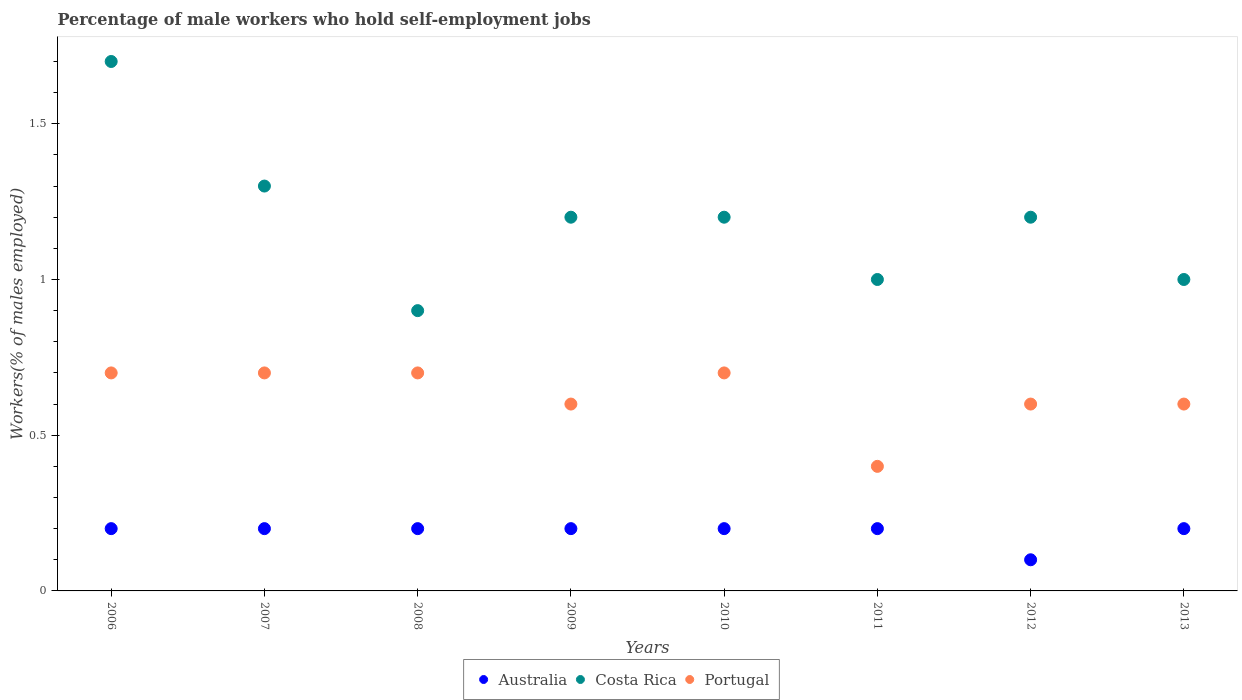How many different coloured dotlines are there?
Offer a very short reply. 3. What is the percentage of self-employed male workers in Australia in 2006?
Keep it short and to the point. 0.2. Across all years, what is the maximum percentage of self-employed male workers in Portugal?
Make the answer very short. 0.7. Across all years, what is the minimum percentage of self-employed male workers in Australia?
Keep it short and to the point. 0.1. What is the total percentage of self-employed male workers in Costa Rica in the graph?
Your answer should be very brief. 9.5. What is the difference between the percentage of self-employed male workers in Portugal in 2007 and that in 2009?
Your answer should be very brief. 0.1. What is the difference between the percentage of self-employed male workers in Australia in 2010 and the percentage of self-employed male workers in Portugal in 2012?
Provide a succinct answer. -0.4. What is the average percentage of self-employed male workers in Australia per year?
Keep it short and to the point. 0.19. In the year 2011, what is the difference between the percentage of self-employed male workers in Australia and percentage of self-employed male workers in Costa Rica?
Make the answer very short. -0.8. What is the ratio of the percentage of self-employed male workers in Costa Rica in 2006 to that in 2009?
Provide a succinct answer. 1.42. Is the percentage of self-employed male workers in Costa Rica in 2010 less than that in 2013?
Make the answer very short. No. Is the difference between the percentage of self-employed male workers in Australia in 2007 and 2010 greater than the difference between the percentage of self-employed male workers in Costa Rica in 2007 and 2010?
Your answer should be very brief. No. What is the difference between the highest and the second highest percentage of self-employed male workers in Costa Rica?
Provide a short and direct response. 0.4. What is the difference between the highest and the lowest percentage of self-employed male workers in Portugal?
Your answer should be very brief. 0.3. In how many years, is the percentage of self-employed male workers in Australia greater than the average percentage of self-employed male workers in Australia taken over all years?
Give a very brief answer. 7. Does the percentage of self-employed male workers in Portugal monotonically increase over the years?
Give a very brief answer. No. How many dotlines are there?
Offer a very short reply. 3. Does the graph contain any zero values?
Make the answer very short. No. Does the graph contain grids?
Provide a succinct answer. No. Where does the legend appear in the graph?
Keep it short and to the point. Bottom center. How many legend labels are there?
Your answer should be compact. 3. What is the title of the graph?
Offer a terse response. Percentage of male workers who hold self-employment jobs. Does "Namibia" appear as one of the legend labels in the graph?
Ensure brevity in your answer.  No. What is the label or title of the Y-axis?
Keep it short and to the point. Workers(% of males employed). What is the Workers(% of males employed) of Australia in 2006?
Give a very brief answer. 0.2. What is the Workers(% of males employed) in Costa Rica in 2006?
Provide a succinct answer. 1.7. What is the Workers(% of males employed) in Portugal in 2006?
Offer a terse response. 0.7. What is the Workers(% of males employed) of Australia in 2007?
Your response must be concise. 0.2. What is the Workers(% of males employed) in Costa Rica in 2007?
Your answer should be very brief. 1.3. What is the Workers(% of males employed) in Portugal in 2007?
Offer a terse response. 0.7. What is the Workers(% of males employed) in Australia in 2008?
Provide a succinct answer. 0.2. What is the Workers(% of males employed) in Costa Rica in 2008?
Your answer should be very brief. 0.9. What is the Workers(% of males employed) of Portugal in 2008?
Make the answer very short. 0.7. What is the Workers(% of males employed) of Australia in 2009?
Keep it short and to the point. 0.2. What is the Workers(% of males employed) in Costa Rica in 2009?
Offer a very short reply. 1.2. What is the Workers(% of males employed) of Portugal in 2009?
Your response must be concise. 0.6. What is the Workers(% of males employed) of Australia in 2010?
Ensure brevity in your answer.  0.2. What is the Workers(% of males employed) of Costa Rica in 2010?
Provide a succinct answer. 1.2. What is the Workers(% of males employed) of Portugal in 2010?
Offer a very short reply. 0.7. What is the Workers(% of males employed) in Australia in 2011?
Keep it short and to the point. 0.2. What is the Workers(% of males employed) of Costa Rica in 2011?
Your answer should be very brief. 1. What is the Workers(% of males employed) of Portugal in 2011?
Your response must be concise. 0.4. What is the Workers(% of males employed) of Australia in 2012?
Ensure brevity in your answer.  0.1. What is the Workers(% of males employed) in Costa Rica in 2012?
Give a very brief answer. 1.2. What is the Workers(% of males employed) in Portugal in 2012?
Your answer should be compact. 0.6. What is the Workers(% of males employed) in Australia in 2013?
Offer a very short reply. 0.2. What is the Workers(% of males employed) in Costa Rica in 2013?
Offer a very short reply. 1. What is the Workers(% of males employed) in Portugal in 2013?
Keep it short and to the point. 0.6. Across all years, what is the maximum Workers(% of males employed) in Australia?
Your answer should be compact. 0.2. Across all years, what is the maximum Workers(% of males employed) in Costa Rica?
Provide a short and direct response. 1.7. Across all years, what is the maximum Workers(% of males employed) of Portugal?
Your response must be concise. 0.7. Across all years, what is the minimum Workers(% of males employed) of Australia?
Keep it short and to the point. 0.1. Across all years, what is the minimum Workers(% of males employed) of Costa Rica?
Offer a very short reply. 0.9. Across all years, what is the minimum Workers(% of males employed) of Portugal?
Provide a succinct answer. 0.4. What is the total Workers(% of males employed) of Australia in the graph?
Your answer should be compact. 1.5. What is the difference between the Workers(% of males employed) in Australia in 2006 and that in 2007?
Ensure brevity in your answer.  0. What is the difference between the Workers(% of males employed) of Portugal in 2006 and that in 2007?
Your response must be concise. 0. What is the difference between the Workers(% of males employed) in Portugal in 2006 and that in 2008?
Provide a succinct answer. 0. What is the difference between the Workers(% of males employed) of Australia in 2006 and that in 2009?
Offer a terse response. 0. What is the difference between the Workers(% of males employed) in Costa Rica in 2006 and that in 2009?
Offer a very short reply. 0.5. What is the difference between the Workers(% of males employed) of Portugal in 2006 and that in 2009?
Give a very brief answer. 0.1. What is the difference between the Workers(% of males employed) in Australia in 2006 and that in 2010?
Ensure brevity in your answer.  0. What is the difference between the Workers(% of males employed) of Portugal in 2006 and that in 2010?
Give a very brief answer. 0. What is the difference between the Workers(% of males employed) of Portugal in 2006 and that in 2011?
Offer a terse response. 0.3. What is the difference between the Workers(% of males employed) of Australia in 2006 and that in 2012?
Make the answer very short. 0.1. What is the difference between the Workers(% of males employed) in Costa Rica in 2006 and that in 2012?
Your response must be concise. 0.5. What is the difference between the Workers(% of males employed) in Portugal in 2006 and that in 2012?
Ensure brevity in your answer.  0.1. What is the difference between the Workers(% of males employed) in Australia in 2006 and that in 2013?
Ensure brevity in your answer.  0. What is the difference between the Workers(% of males employed) of Costa Rica in 2006 and that in 2013?
Ensure brevity in your answer.  0.7. What is the difference between the Workers(% of males employed) of Portugal in 2006 and that in 2013?
Your answer should be compact. 0.1. What is the difference between the Workers(% of males employed) of Costa Rica in 2007 and that in 2008?
Give a very brief answer. 0.4. What is the difference between the Workers(% of males employed) in Costa Rica in 2007 and that in 2009?
Offer a very short reply. 0.1. What is the difference between the Workers(% of males employed) of Australia in 2007 and that in 2011?
Keep it short and to the point. 0. What is the difference between the Workers(% of males employed) in Costa Rica in 2007 and that in 2011?
Ensure brevity in your answer.  0.3. What is the difference between the Workers(% of males employed) of Portugal in 2007 and that in 2011?
Give a very brief answer. 0.3. What is the difference between the Workers(% of males employed) in Costa Rica in 2007 and that in 2012?
Offer a terse response. 0.1. What is the difference between the Workers(% of males employed) of Portugal in 2007 and that in 2012?
Provide a short and direct response. 0.1. What is the difference between the Workers(% of males employed) of Portugal in 2007 and that in 2013?
Keep it short and to the point. 0.1. What is the difference between the Workers(% of males employed) in Australia in 2008 and that in 2009?
Your answer should be compact. 0. What is the difference between the Workers(% of males employed) of Costa Rica in 2008 and that in 2010?
Your answer should be very brief. -0.3. What is the difference between the Workers(% of males employed) of Portugal in 2008 and that in 2010?
Give a very brief answer. 0. What is the difference between the Workers(% of males employed) in Costa Rica in 2008 and that in 2013?
Keep it short and to the point. -0.1. What is the difference between the Workers(% of males employed) in Australia in 2009 and that in 2010?
Keep it short and to the point. 0. What is the difference between the Workers(% of males employed) in Costa Rica in 2009 and that in 2010?
Make the answer very short. 0. What is the difference between the Workers(% of males employed) of Portugal in 2009 and that in 2010?
Offer a very short reply. -0.1. What is the difference between the Workers(% of males employed) in Australia in 2009 and that in 2012?
Provide a short and direct response. 0.1. What is the difference between the Workers(% of males employed) of Costa Rica in 2009 and that in 2013?
Your answer should be compact. 0.2. What is the difference between the Workers(% of males employed) in Portugal in 2009 and that in 2013?
Give a very brief answer. 0. What is the difference between the Workers(% of males employed) in Australia in 2010 and that in 2011?
Provide a short and direct response. 0. What is the difference between the Workers(% of males employed) of Portugal in 2010 and that in 2011?
Your answer should be very brief. 0.3. What is the difference between the Workers(% of males employed) of Australia in 2010 and that in 2013?
Your response must be concise. 0. What is the difference between the Workers(% of males employed) in Costa Rica in 2010 and that in 2013?
Provide a short and direct response. 0.2. What is the difference between the Workers(% of males employed) of Australia in 2011 and that in 2012?
Your response must be concise. 0.1. What is the difference between the Workers(% of males employed) in Costa Rica in 2011 and that in 2012?
Ensure brevity in your answer.  -0.2. What is the difference between the Workers(% of males employed) in Portugal in 2011 and that in 2012?
Your response must be concise. -0.2. What is the difference between the Workers(% of males employed) of Costa Rica in 2011 and that in 2013?
Give a very brief answer. 0. What is the difference between the Workers(% of males employed) of Portugal in 2011 and that in 2013?
Keep it short and to the point. -0.2. What is the difference between the Workers(% of males employed) in Portugal in 2012 and that in 2013?
Your answer should be compact. 0. What is the difference between the Workers(% of males employed) in Australia in 2006 and the Workers(% of males employed) in Costa Rica in 2007?
Keep it short and to the point. -1.1. What is the difference between the Workers(% of males employed) of Australia in 2006 and the Workers(% of males employed) of Costa Rica in 2008?
Provide a short and direct response. -0.7. What is the difference between the Workers(% of males employed) in Australia in 2006 and the Workers(% of males employed) in Portugal in 2008?
Offer a very short reply. -0.5. What is the difference between the Workers(% of males employed) in Costa Rica in 2006 and the Workers(% of males employed) in Portugal in 2008?
Your answer should be very brief. 1. What is the difference between the Workers(% of males employed) of Costa Rica in 2006 and the Workers(% of males employed) of Portugal in 2009?
Your answer should be very brief. 1.1. What is the difference between the Workers(% of males employed) in Australia in 2006 and the Workers(% of males employed) in Costa Rica in 2010?
Provide a succinct answer. -1. What is the difference between the Workers(% of males employed) in Australia in 2006 and the Workers(% of males employed) in Portugal in 2011?
Offer a terse response. -0.2. What is the difference between the Workers(% of males employed) of Australia in 2006 and the Workers(% of males employed) of Costa Rica in 2012?
Offer a terse response. -1. What is the difference between the Workers(% of males employed) of Australia in 2006 and the Workers(% of males employed) of Portugal in 2013?
Offer a terse response. -0.4. What is the difference between the Workers(% of males employed) of Costa Rica in 2006 and the Workers(% of males employed) of Portugal in 2013?
Give a very brief answer. 1.1. What is the difference between the Workers(% of males employed) of Australia in 2007 and the Workers(% of males employed) of Costa Rica in 2008?
Give a very brief answer. -0.7. What is the difference between the Workers(% of males employed) of Australia in 2007 and the Workers(% of males employed) of Costa Rica in 2010?
Offer a very short reply. -1. What is the difference between the Workers(% of males employed) in Australia in 2007 and the Workers(% of males employed) in Portugal in 2010?
Your response must be concise. -0.5. What is the difference between the Workers(% of males employed) of Australia in 2007 and the Workers(% of males employed) of Costa Rica in 2011?
Your answer should be compact. -0.8. What is the difference between the Workers(% of males employed) of Costa Rica in 2007 and the Workers(% of males employed) of Portugal in 2011?
Offer a terse response. 0.9. What is the difference between the Workers(% of males employed) of Australia in 2007 and the Workers(% of males employed) of Costa Rica in 2013?
Make the answer very short. -0.8. What is the difference between the Workers(% of males employed) of Australia in 2007 and the Workers(% of males employed) of Portugal in 2013?
Offer a terse response. -0.4. What is the difference between the Workers(% of males employed) in Costa Rica in 2007 and the Workers(% of males employed) in Portugal in 2013?
Your answer should be very brief. 0.7. What is the difference between the Workers(% of males employed) of Australia in 2008 and the Workers(% of males employed) of Costa Rica in 2009?
Make the answer very short. -1. What is the difference between the Workers(% of males employed) of Costa Rica in 2008 and the Workers(% of males employed) of Portugal in 2009?
Your response must be concise. 0.3. What is the difference between the Workers(% of males employed) of Australia in 2008 and the Workers(% of males employed) of Costa Rica in 2010?
Your answer should be compact. -1. What is the difference between the Workers(% of males employed) of Australia in 2008 and the Workers(% of males employed) of Portugal in 2010?
Provide a short and direct response. -0.5. What is the difference between the Workers(% of males employed) of Costa Rica in 2008 and the Workers(% of males employed) of Portugal in 2010?
Provide a succinct answer. 0.2. What is the difference between the Workers(% of males employed) in Costa Rica in 2008 and the Workers(% of males employed) in Portugal in 2011?
Your response must be concise. 0.5. What is the difference between the Workers(% of males employed) in Australia in 2008 and the Workers(% of males employed) in Costa Rica in 2012?
Your answer should be very brief. -1. What is the difference between the Workers(% of males employed) of Australia in 2008 and the Workers(% of males employed) of Portugal in 2012?
Make the answer very short. -0.4. What is the difference between the Workers(% of males employed) of Costa Rica in 2008 and the Workers(% of males employed) of Portugal in 2012?
Give a very brief answer. 0.3. What is the difference between the Workers(% of males employed) of Australia in 2008 and the Workers(% of males employed) of Costa Rica in 2013?
Give a very brief answer. -0.8. What is the difference between the Workers(% of males employed) in Australia in 2009 and the Workers(% of males employed) in Costa Rica in 2010?
Keep it short and to the point. -1. What is the difference between the Workers(% of males employed) of Costa Rica in 2009 and the Workers(% of males employed) of Portugal in 2010?
Keep it short and to the point. 0.5. What is the difference between the Workers(% of males employed) of Australia in 2009 and the Workers(% of males employed) of Portugal in 2011?
Give a very brief answer. -0.2. What is the difference between the Workers(% of males employed) of Australia in 2009 and the Workers(% of males employed) of Portugal in 2012?
Your answer should be compact. -0.4. What is the difference between the Workers(% of males employed) of Costa Rica in 2009 and the Workers(% of males employed) of Portugal in 2012?
Your answer should be compact. 0.6. What is the difference between the Workers(% of males employed) in Australia in 2010 and the Workers(% of males employed) in Costa Rica in 2011?
Offer a very short reply. -0.8. What is the difference between the Workers(% of males employed) in Australia in 2010 and the Workers(% of males employed) in Portugal in 2012?
Give a very brief answer. -0.4. What is the difference between the Workers(% of males employed) of Australia in 2010 and the Workers(% of males employed) of Portugal in 2013?
Ensure brevity in your answer.  -0.4. What is the difference between the Workers(% of males employed) of Costa Rica in 2011 and the Workers(% of males employed) of Portugal in 2012?
Provide a succinct answer. 0.4. What is the difference between the Workers(% of males employed) in Australia in 2011 and the Workers(% of males employed) in Costa Rica in 2013?
Make the answer very short. -0.8. What is the difference between the Workers(% of males employed) in Australia in 2011 and the Workers(% of males employed) in Portugal in 2013?
Provide a short and direct response. -0.4. What is the difference between the Workers(% of males employed) in Costa Rica in 2011 and the Workers(% of males employed) in Portugal in 2013?
Your answer should be compact. 0.4. What is the difference between the Workers(% of males employed) of Costa Rica in 2012 and the Workers(% of males employed) of Portugal in 2013?
Keep it short and to the point. 0.6. What is the average Workers(% of males employed) of Australia per year?
Offer a terse response. 0.19. What is the average Workers(% of males employed) of Costa Rica per year?
Your response must be concise. 1.19. What is the average Workers(% of males employed) in Portugal per year?
Give a very brief answer. 0.62. In the year 2006, what is the difference between the Workers(% of males employed) in Australia and Workers(% of males employed) in Portugal?
Your answer should be compact. -0.5. In the year 2006, what is the difference between the Workers(% of males employed) in Costa Rica and Workers(% of males employed) in Portugal?
Your answer should be very brief. 1. In the year 2008, what is the difference between the Workers(% of males employed) of Australia and Workers(% of males employed) of Portugal?
Keep it short and to the point. -0.5. In the year 2008, what is the difference between the Workers(% of males employed) of Costa Rica and Workers(% of males employed) of Portugal?
Offer a very short reply. 0.2. In the year 2009, what is the difference between the Workers(% of males employed) in Australia and Workers(% of males employed) in Costa Rica?
Ensure brevity in your answer.  -1. In the year 2009, what is the difference between the Workers(% of males employed) in Australia and Workers(% of males employed) in Portugal?
Provide a succinct answer. -0.4. In the year 2009, what is the difference between the Workers(% of males employed) in Costa Rica and Workers(% of males employed) in Portugal?
Your answer should be compact. 0.6. In the year 2010, what is the difference between the Workers(% of males employed) of Australia and Workers(% of males employed) of Costa Rica?
Make the answer very short. -1. In the year 2010, what is the difference between the Workers(% of males employed) in Australia and Workers(% of males employed) in Portugal?
Ensure brevity in your answer.  -0.5. In the year 2010, what is the difference between the Workers(% of males employed) in Costa Rica and Workers(% of males employed) in Portugal?
Offer a very short reply. 0.5. In the year 2012, what is the difference between the Workers(% of males employed) in Australia and Workers(% of males employed) in Costa Rica?
Keep it short and to the point. -1.1. In the year 2012, what is the difference between the Workers(% of males employed) of Australia and Workers(% of males employed) of Portugal?
Make the answer very short. -0.5. In the year 2012, what is the difference between the Workers(% of males employed) of Costa Rica and Workers(% of males employed) of Portugal?
Your answer should be very brief. 0.6. In the year 2013, what is the difference between the Workers(% of males employed) of Australia and Workers(% of males employed) of Costa Rica?
Offer a very short reply. -0.8. What is the ratio of the Workers(% of males employed) in Costa Rica in 2006 to that in 2007?
Give a very brief answer. 1.31. What is the ratio of the Workers(% of males employed) of Costa Rica in 2006 to that in 2008?
Provide a short and direct response. 1.89. What is the ratio of the Workers(% of males employed) in Portugal in 2006 to that in 2008?
Ensure brevity in your answer.  1. What is the ratio of the Workers(% of males employed) of Australia in 2006 to that in 2009?
Provide a short and direct response. 1. What is the ratio of the Workers(% of males employed) of Costa Rica in 2006 to that in 2009?
Your answer should be very brief. 1.42. What is the ratio of the Workers(% of males employed) in Costa Rica in 2006 to that in 2010?
Keep it short and to the point. 1.42. What is the ratio of the Workers(% of males employed) in Portugal in 2006 to that in 2010?
Offer a terse response. 1. What is the ratio of the Workers(% of males employed) in Australia in 2006 to that in 2011?
Keep it short and to the point. 1. What is the ratio of the Workers(% of males employed) of Australia in 2006 to that in 2012?
Provide a succinct answer. 2. What is the ratio of the Workers(% of males employed) of Costa Rica in 2006 to that in 2012?
Provide a short and direct response. 1.42. What is the ratio of the Workers(% of males employed) in Portugal in 2006 to that in 2012?
Provide a succinct answer. 1.17. What is the ratio of the Workers(% of males employed) in Australia in 2006 to that in 2013?
Ensure brevity in your answer.  1. What is the ratio of the Workers(% of males employed) of Costa Rica in 2006 to that in 2013?
Your answer should be compact. 1.7. What is the ratio of the Workers(% of males employed) of Portugal in 2006 to that in 2013?
Your answer should be compact. 1.17. What is the ratio of the Workers(% of males employed) in Australia in 2007 to that in 2008?
Make the answer very short. 1. What is the ratio of the Workers(% of males employed) of Costa Rica in 2007 to that in 2008?
Give a very brief answer. 1.44. What is the ratio of the Workers(% of males employed) in Portugal in 2007 to that in 2008?
Offer a terse response. 1. What is the ratio of the Workers(% of males employed) of Australia in 2007 to that in 2009?
Keep it short and to the point. 1. What is the ratio of the Workers(% of males employed) of Costa Rica in 2007 to that in 2009?
Give a very brief answer. 1.08. What is the ratio of the Workers(% of males employed) of Australia in 2007 to that in 2010?
Keep it short and to the point. 1. What is the ratio of the Workers(% of males employed) in Costa Rica in 2007 to that in 2010?
Keep it short and to the point. 1.08. What is the ratio of the Workers(% of males employed) in Portugal in 2007 to that in 2010?
Offer a terse response. 1. What is the ratio of the Workers(% of males employed) in Australia in 2007 to that in 2011?
Offer a terse response. 1. What is the ratio of the Workers(% of males employed) in Costa Rica in 2007 to that in 2011?
Your answer should be compact. 1.3. What is the ratio of the Workers(% of males employed) of Portugal in 2007 to that in 2011?
Your answer should be very brief. 1.75. What is the ratio of the Workers(% of males employed) of Costa Rica in 2007 to that in 2012?
Your response must be concise. 1.08. What is the ratio of the Workers(% of males employed) in Portugal in 2007 to that in 2012?
Provide a short and direct response. 1.17. What is the ratio of the Workers(% of males employed) in Australia in 2007 to that in 2013?
Your answer should be compact. 1. What is the ratio of the Workers(% of males employed) of Australia in 2008 to that in 2009?
Offer a terse response. 1. What is the ratio of the Workers(% of males employed) of Portugal in 2008 to that in 2009?
Provide a succinct answer. 1.17. What is the ratio of the Workers(% of males employed) of Australia in 2008 to that in 2010?
Provide a succinct answer. 1. What is the ratio of the Workers(% of males employed) in Costa Rica in 2008 to that in 2010?
Give a very brief answer. 0.75. What is the ratio of the Workers(% of males employed) in Costa Rica in 2008 to that in 2011?
Ensure brevity in your answer.  0.9. What is the ratio of the Workers(% of males employed) of Australia in 2008 to that in 2012?
Ensure brevity in your answer.  2. What is the ratio of the Workers(% of males employed) of Costa Rica in 2008 to that in 2012?
Your response must be concise. 0.75. What is the ratio of the Workers(% of males employed) of Portugal in 2008 to that in 2012?
Your response must be concise. 1.17. What is the ratio of the Workers(% of males employed) of Costa Rica in 2008 to that in 2013?
Provide a succinct answer. 0.9. What is the ratio of the Workers(% of males employed) in Portugal in 2008 to that in 2013?
Your answer should be compact. 1.17. What is the ratio of the Workers(% of males employed) of Australia in 2009 to that in 2010?
Offer a terse response. 1. What is the ratio of the Workers(% of males employed) in Costa Rica in 2009 to that in 2011?
Your answer should be very brief. 1.2. What is the ratio of the Workers(% of males employed) of Portugal in 2009 to that in 2011?
Keep it short and to the point. 1.5. What is the ratio of the Workers(% of males employed) of Australia in 2009 to that in 2012?
Offer a terse response. 2. What is the ratio of the Workers(% of males employed) in Costa Rica in 2009 to that in 2012?
Give a very brief answer. 1. What is the ratio of the Workers(% of males employed) of Australia in 2009 to that in 2013?
Your response must be concise. 1. What is the ratio of the Workers(% of males employed) of Costa Rica in 2009 to that in 2013?
Your answer should be very brief. 1.2. What is the ratio of the Workers(% of males employed) in Portugal in 2009 to that in 2013?
Your answer should be very brief. 1. What is the ratio of the Workers(% of males employed) in Costa Rica in 2010 to that in 2011?
Give a very brief answer. 1.2. What is the ratio of the Workers(% of males employed) in Portugal in 2010 to that in 2011?
Your answer should be very brief. 1.75. What is the ratio of the Workers(% of males employed) of Costa Rica in 2010 to that in 2012?
Your answer should be very brief. 1. What is the ratio of the Workers(% of males employed) in Portugal in 2010 to that in 2012?
Offer a very short reply. 1.17. What is the ratio of the Workers(% of males employed) of Australia in 2010 to that in 2013?
Offer a very short reply. 1. What is the ratio of the Workers(% of males employed) of Costa Rica in 2010 to that in 2013?
Offer a very short reply. 1.2. What is the ratio of the Workers(% of males employed) in Australia in 2011 to that in 2012?
Your answer should be very brief. 2. What is the ratio of the Workers(% of males employed) of Costa Rica in 2011 to that in 2012?
Provide a succinct answer. 0.83. What is the ratio of the Workers(% of males employed) of Portugal in 2011 to that in 2012?
Your response must be concise. 0.67. What is the ratio of the Workers(% of males employed) in Australia in 2011 to that in 2013?
Your response must be concise. 1. What is the ratio of the Workers(% of males employed) of Costa Rica in 2012 to that in 2013?
Keep it short and to the point. 1.2. What is the ratio of the Workers(% of males employed) in Portugal in 2012 to that in 2013?
Make the answer very short. 1. What is the difference between the highest and the second highest Workers(% of males employed) of Australia?
Give a very brief answer. 0. What is the difference between the highest and the second highest Workers(% of males employed) in Costa Rica?
Make the answer very short. 0.4. 